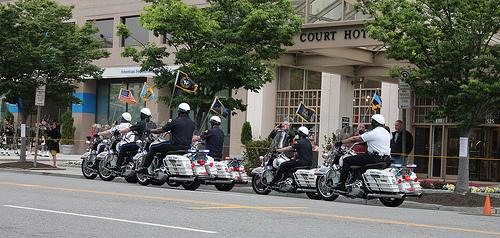Describe the lines present in the middle of the street. There is a yellow strip and a white strip in the middle of the street. Describe the flags being held by the motorcyclists in the parade. The flags are blue with gold trim. Provide a brief sentiment analysis of the image's atmosphere. The image has a positive and orderly atmosphere, as police officers are parading together in unity. What natural element is present in the image and describe its appearance? A tree with a lot of green leaves is in front of a building. Mention an object in the image that is related to traffic control and describe its location. An orange traffic cone, located in the middle of the street. Count the number of motorcyclists holding flags. There are six motorcyclists holding flags in total. What type of vehicle is the primary focus in the image, and how many of them are there? Motorcycles are the primary focus, and there are six motorcycles. Identify the main event taking place in the image and provide a brief explanation. A parade of motorcycle policemen is happening, where they are driving together, holding flags, and wearing white helmets. List three types of people seen watching the police officers. A man standing by, a woman in a black shirt, and a woman near a tree. Provide a description of the writing on the building and its color. The writing on the building is black and contains the word "court." Are the trees in the background pink with purple leaves? There are trees in the image, but they are described as green and leafy, not pink with purple leaves. Is the woman wearing a red shirt standing next to the tree? There is a woman in the picture, but she is wearing a black shirt, not a red one. Is there a tall building in the far distance with a clock at the top? No, it's not mentioned in the image. Can you see a dog sitting near the orange cone in the middle of the road? There is an orange cone in the picture, but there is no mention of a dog sitting near it. Does the man on the motorcycle have a green helmet? There are men on motorcycles, but the helmets mentioned are white, not green. Do you notice any black and yellow striped flags on the motorcycles? There are flags mentioned in the image, but they are blue with gold trim, not black and yellow striped. 